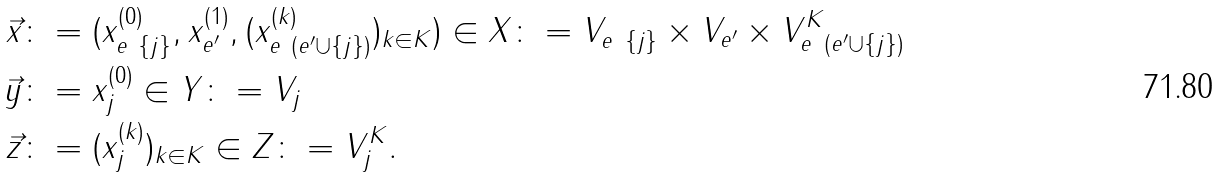Convert formula to latex. <formula><loc_0><loc_0><loc_500><loc_500>\vec { x } & \colon = ( x ^ { ( 0 ) } _ { e \ \{ j \} } , x ^ { ( 1 ) } _ { e ^ { \prime } } , ( x ^ { ( k ) } _ { e \ ( e ^ { \prime } \cup \{ j \} ) } ) _ { k \in K } ) \in X \colon = V _ { e \ \{ j \} } \times V _ { e ^ { \prime } } \times V _ { e \ ( e ^ { \prime } \cup \{ j \} ) } ^ { K } \\ \vec { y } & \colon = x ^ { ( 0 ) } _ { j } \in Y \colon = V _ { j } \\ \vec { z } & \colon = ( x ^ { ( k ) } _ { j } ) _ { k \in K } \in Z \colon = V _ { j } ^ { K } .</formula> 